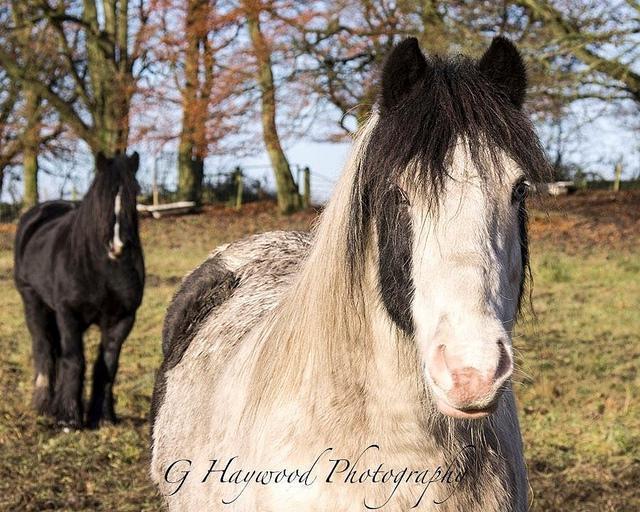How many horses are there?
Give a very brief answer. 2. How many horses are visible?
Give a very brief answer. 2. How many toothbrushes is this?
Give a very brief answer. 0. 